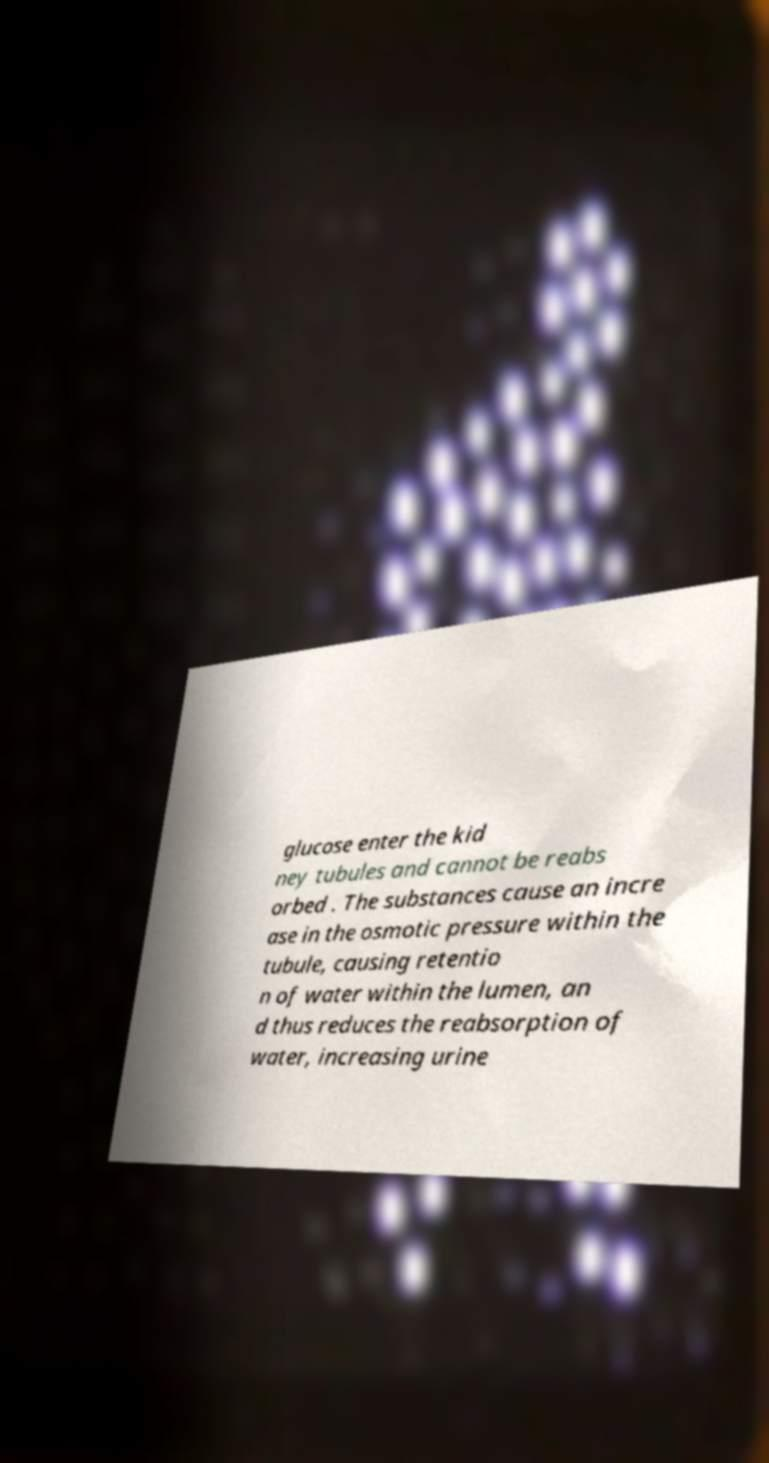For documentation purposes, I need the text within this image transcribed. Could you provide that? glucose enter the kid ney tubules and cannot be reabs orbed . The substances cause an incre ase in the osmotic pressure within the tubule, causing retentio n of water within the lumen, an d thus reduces the reabsorption of water, increasing urine 